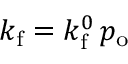<formula> <loc_0><loc_0><loc_500><loc_500>k _ { f } = k _ { f } ^ { 0 } \, p _ { o }</formula> 